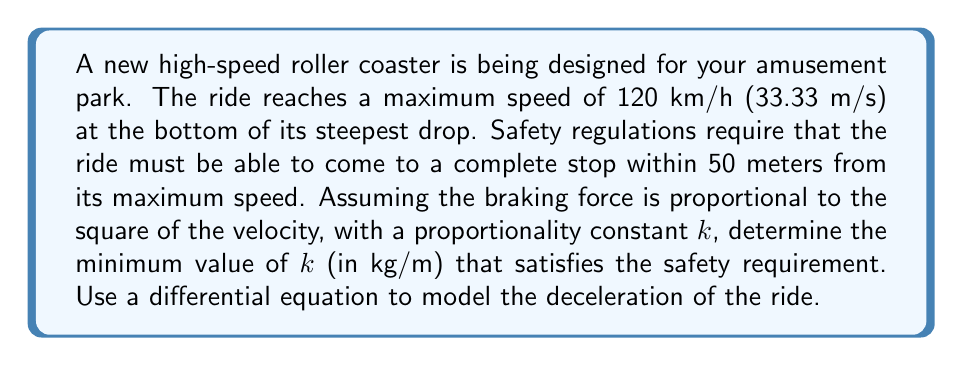Can you solve this math problem? Let's approach this problem step by step:

1) First, we need to set up our differential equation. Let $v$ be the velocity of the roller coaster and $x$ be the distance traveled. The braking force is proportional to $v^2$, so we can write:

   $$m\frac{dv}{dt} = -kv^2$$

   where $m$ is the mass of the roller coaster and $k$ is the proportionality constant we need to find.

2) We can rewrite this in terms of $x$ instead of $t$ using the chain rule:

   $$m\frac{dv}{dx}\frac{dx}{dt} = -kv^2$$

   Since $\frac{dx}{dt} = v$, we get:

   $$mv\frac{dv}{dx} = -kv^2$$

3) Simplifying:

   $$m\frac{dv}{dx} = -kv$$

4) Separating variables:

   $$\frac{m}{v}dv = -kdx$$

5) Integrating both sides:

   $$m\int_{v_0}^{v_f} \frac{1}{v}dv = -k\int_0^{x_f} dx$$

   where $v_0 = 33.33$ m/s (initial velocity), $v_f = 0$ m/s (final velocity), and $x_f = 50$ m (stopping distance).

6) Solving the integrals:

   $$m[\ln|v|]_{v_0}^{v_f} = -kx_f$$

   $$m(\ln|0| - \ln|33.33|) = -50k$$

7) Since $\ln|0|$ is undefined, we need to approach this limit:

   $$\lim_{v_f \to 0} m(\ln|v_f| - \ln|33.33|) = -50k$$

   $$m(-\infty - \ln|33.33|) = -50k$$

8) For this equation to be true, $k$ must approach:

   $$k = \frac{m\ln|33.33|}{50}$$

9) The mass $m$ cancels out in this equation, so the minimum value of $k$ is:

   $$k = \frac{\ln|33.33|}{50} \approx 0.0698$$ kg/m

Therefore, the minimum value of $k$ that satisfies the safety requirement is approximately 0.0698 kg/m.
Answer: The minimum value of $k$ is approximately 0.0698 kg/m. 